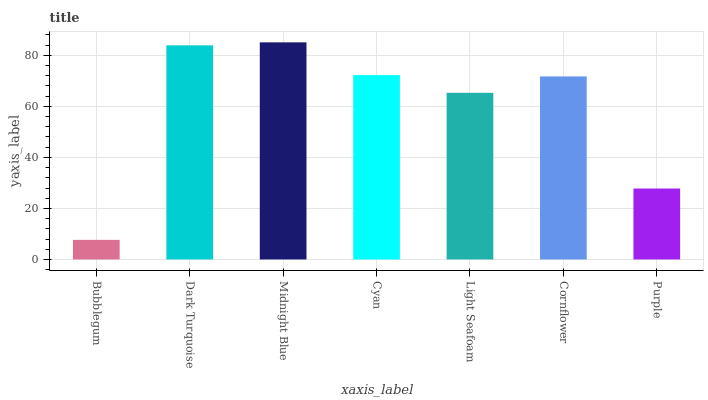Is Bubblegum the minimum?
Answer yes or no. Yes. Is Midnight Blue the maximum?
Answer yes or no. Yes. Is Dark Turquoise the minimum?
Answer yes or no. No. Is Dark Turquoise the maximum?
Answer yes or no. No. Is Dark Turquoise greater than Bubblegum?
Answer yes or no. Yes. Is Bubblegum less than Dark Turquoise?
Answer yes or no. Yes. Is Bubblegum greater than Dark Turquoise?
Answer yes or no. No. Is Dark Turquoise less than Bubblegum?
Answer yes or no. No. Is Cornflower the high median?
Answer yes or no. Yes. Is Cornflower the low median?
Answer yes or no. Yes. Is Bubblegum the high median?
Answer yes or no. No. Is Light Seafoam the low median?
Answer yes or no. No. 